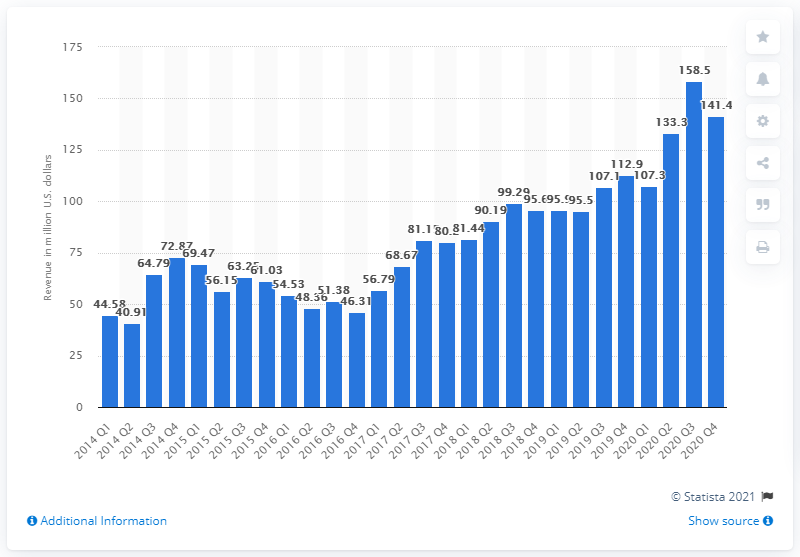Indicate a few pertinent items in this graphic. Glu Mobile generated $141.4 million in revenue in the fourth quarter of 2020. In the first quarter of 2020, Glu Mobile's revenue was 107.3 million dollars. 